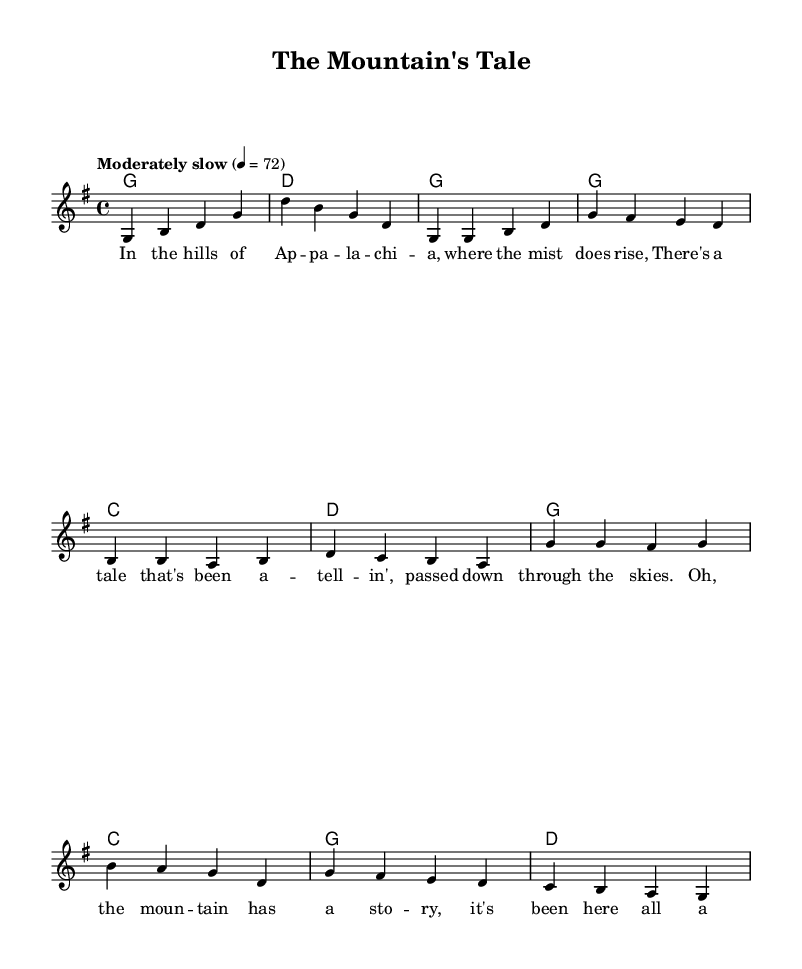What is the key signature of this music? The key signature indicates the piece is in G major, which has one sharp (F sharp). This can be observed at the beginning of the score where the key signature is notated.
Answer: G major What is the time signature of the piece? The time signature shown at the beginning of the score is 4/4, which means there are four beats per measure and the quarter note gets one beat. This can be seen right after the key signature in the staff notation.
Answer: 4/4 What is the tempo marking for this music? The tempo marking states "Moderately slow" with a tempo of 72 beats per minute, which is indicated just below the title. It tells the performer to play at a moderate speed.
Answer: Moderately slow How many measures are there in the chorus section? The chorus section, as indicated by the structure of the lyrics and the corresponding melody, consists of four measures. By counting the notated measures, we find that there are four distinct musical units in the chorus.
Answer: Four What themes are conveyed in the lyrics of the ballad? The lyrics focus on storytelling and a connection to heritage and history, which are common themes in Appalachian folk ballads. This can be derived from the phrases included in the lyric sections discussing tales passed down and the mountain's story.
Answer: Storytelling and oral history What chord is played during the intro? The chord played during the intro is G major, which is the first chord listed in the harmonies section of the score for the opening measures.
Answer: G major 